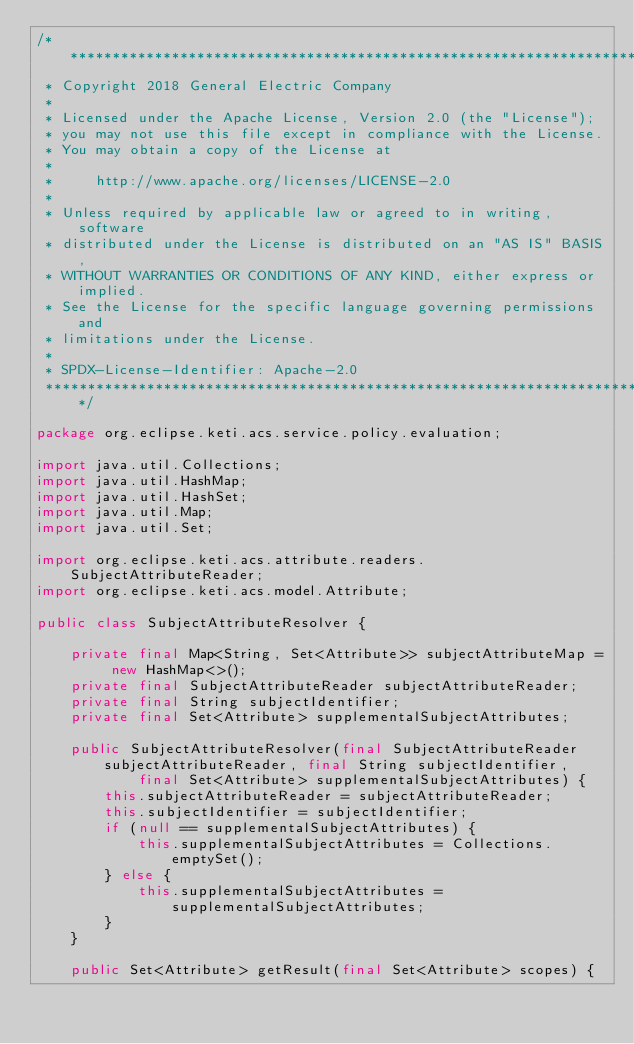Convert code to text. <code><loc_0><loc_0><loc_500><loc_500><_Java_>/*******************************************************************************
 * Copyright 2018 General Electric Company
 *
 * Licensed under the Apache License, Version 2.0 (the "License");
 * you may not use this file except in compliance with the License.
 * You may obtain a copy of the License at
 *
 *     http://www.apache.org/licenses/LICENSE-2.0
 *
 * Unless required by applicable law or agreed to in writing, software
 * distributed under the License is distributed on an "AS IS" BASIS,
 * WITHOUT WARRANTIES OR CONDITIONS OF ANY KIND, either express or implied.
 * See the License for the specific language governing permissions and
 * limitations under the License.
 *
 * SPDX-License-Identifier: Apache-2.0
 *******************************************************************************/

package org.eclipse.keti.acs.service.policy.evaluation;

import java.util.Collections;
import java.util.HashMap;
import java.util.HashSet;
import java.util.Map;
import java.util.Set;

import org.eclipse.keti.acs.attribute.readers.SubjectAttributeReader;
import org.eclipse.keti.acs.model.Attribute;

public class SubjectAttributeResolver {

    private final Map<String, Set<Attribute>> subjectAttributeMap = new HashMap<>();
    private final SubjectAttributeReader subjectAttributeReader;
    private final String subjectIdentifier;
    private final Set<Attribute> supplementalSubjectAttributes;

    public SubjectAttributeResolver(final SubjectAttributeReader subjectAttributeReader, final String subjectIdentifier,
            final Set<Attribute> supplementalSubjectAttributes) {
        this.subjectAttributeReader = subjectAttributeReader;
        this.subjectIdentifier = subjectIdentifier;
        if (null == supplementalSubjectAttributes) {
            this.supplementalSubjectAttributes = Collections.emptySet();
        } else {
            this.supplementalSubjectAttributes = supplementalSubjectAttributes;
        }
    }

    public Set<Attribute> getResult(final Set<Attribute> scopes) {</code> 